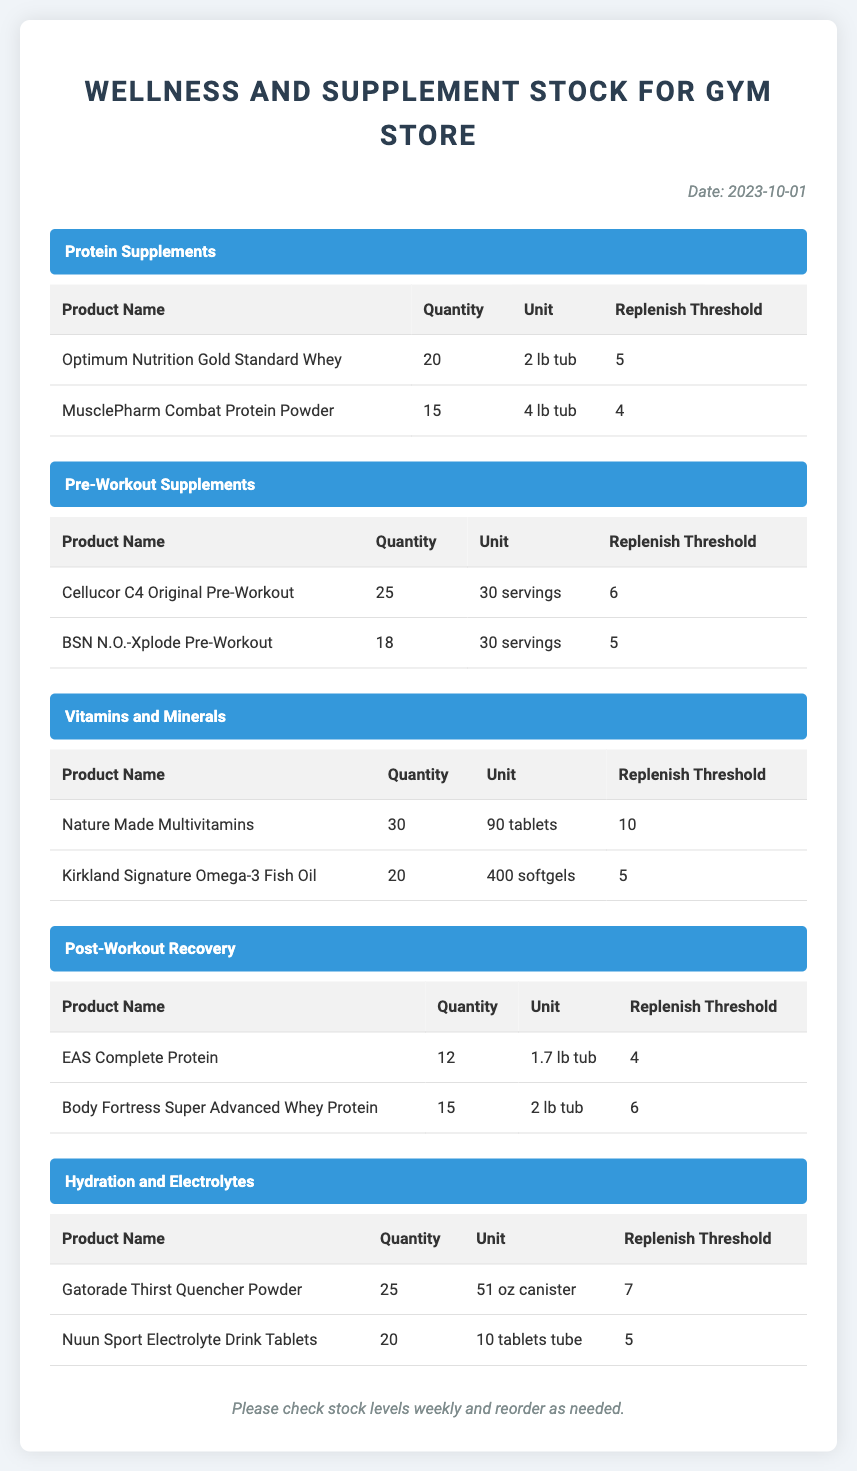What is the date of the report? The date is found at the top of the document under the date section.
Answer: 2023-10-01 How many units of Optimum Nutrition Gold Standard Whey are in stock? The quantity is listed in the Protein Supplements section of the document.
Answer: 20 What is the replenish threshold for Cellucor C4 Original Pre-Workout? The replenish threshold is listed alongside the quantity for each product in the Pre-Workout Supplements category.
Answer: 6 How many vitamins and minerals products are listed? The number of products can be counted in the Vitamins and Minerals category.
Answer: 2 Which post-workout recovery product has the lowest stock? This question relates to comparing the quantities of post-workout recovery products listed.
Answer: EAS Complete Protein What is the total quantity of hydration and electrolytes stocked? The total can be calculated by adding the quantities from the Hydration and Electrolytes category.
Answer: 45 Which product requires replenishing based on the low stock indicator? This refers to products with quantities equal to or below their replenish thresholds.
Answer: Body Fortress Super Advanced Whey Protein What is the unit of the Kirkland Signature Omega-3 Fish Oil? The unit for each product is specified in the Vitamins and Minerals section.
Answer: 400 softgels How many servings are in a tub of MusclePharm Combat Protein Powder? The servings are described in the unit column for the product in the Protein Supplements section.
Answer: 4 lb tub 